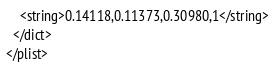Convert code to text. <code><loc_0><loc_0><loc_500><loc_500><_XML_>    <string>0.14118,0.11373,0.30980,1</string>
  </dict>
</plist>
</code> 